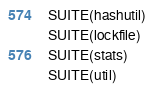Convert code to text. <code><loc_0><loc_0><loc_500><loc_500><_C_>SUITE(hashutil)
SUITE(lockfile)
SUITE(stats)
SUITE(util)
</code> 